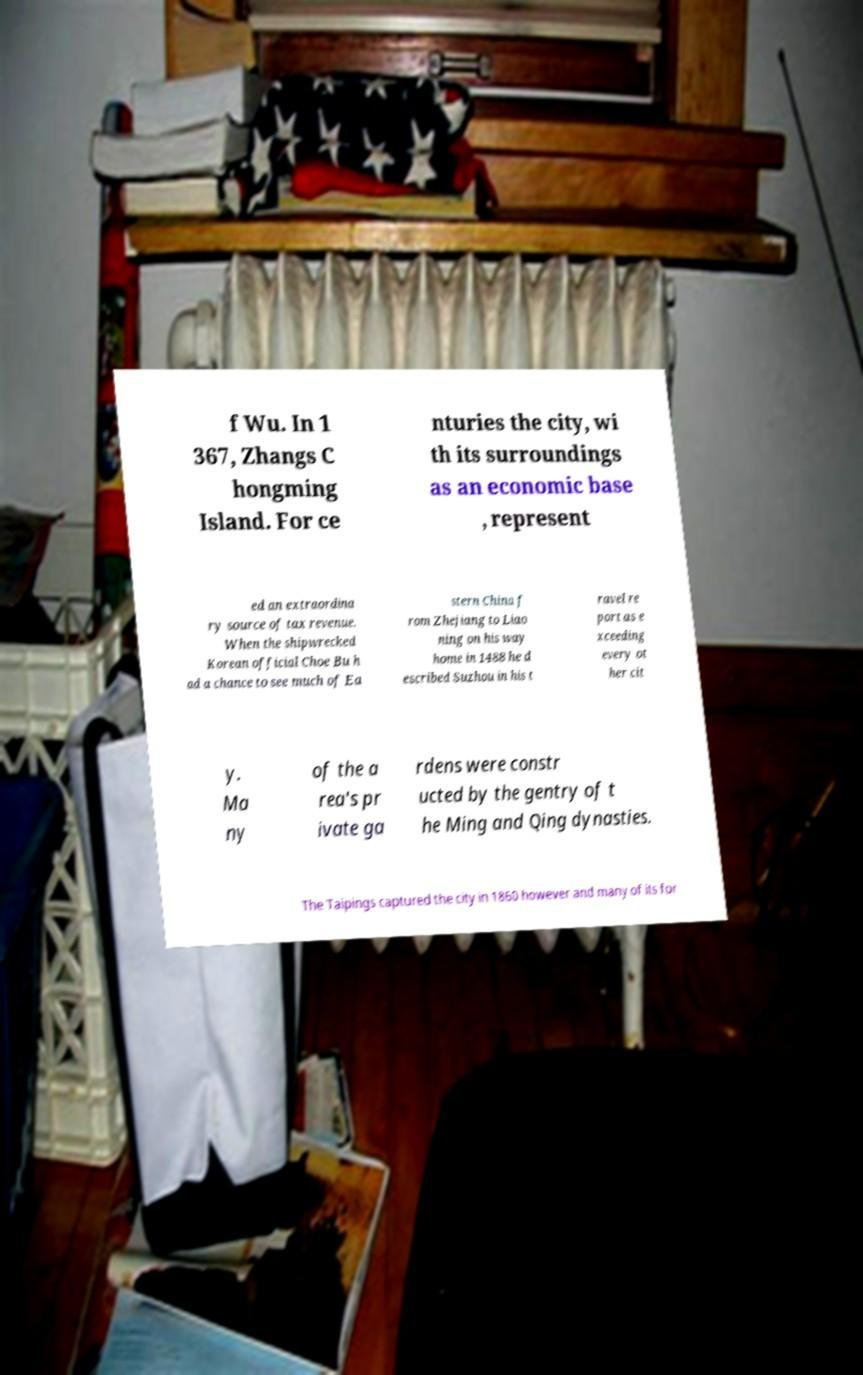Can you accurately transcribe the text from the provided image for me? f Wu. In 1 367, Zhangs C hongming Island. For ce nturies the city, wi th its surroundings as an economic base , represent ed an extraordina ry source of tax revenue. When the shipwrecked Korean official Choe Bu h ad a chance to see much of Ea stern China f rom Zhejiang to Liao ning on his way home in 1488 he d escribed Suzhou in his t ravel re port as e xceeding every ot her cit y. Ma ny of the a rea's pr ivate ga rdens were constr ucted by the gentry of t he Ming and Qing dynasties. The Taipings captured the city in 1860 however and many of its for 